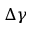Convert formula to latex. <formula><loc_0><loc_0><loc_500><loc_500>\Delta \gamma</formula> 